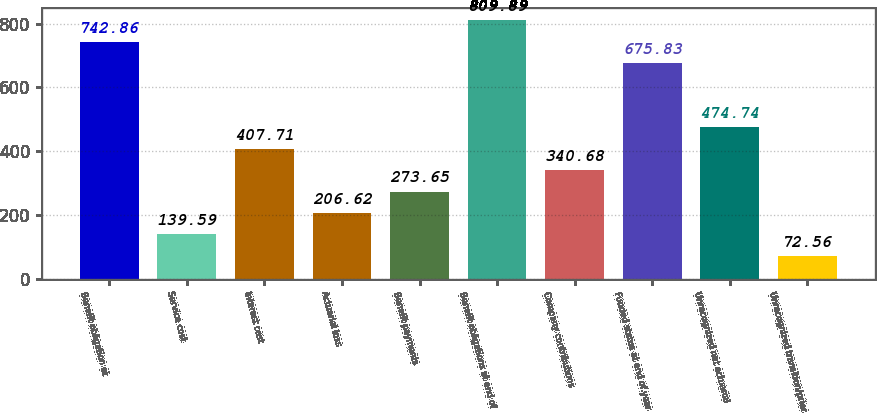Convert chart. <chart><loc_0><loc_0><loc_500><loc_500><bar_chart><fcel>Benefit obligation at<fcel>Service cost<fcel>Interest cost<fcel>Actuarial loss<fcel>Benefit payments<fcel>Benefit obligations at end of<fcel>Company contributions<fcel>Funded status at end of year<fcel>Unrecognized net actuarial<fcel>Unrecognized transition/prior<nl><fcel>742.86<fcel>139.59<fcel>407.71<fcel>206.62<fcel>273.65<fcel>809.89<fcel>340.68<fcel>675.83<fcel>474.74<fcel>72.56<nl></chart> 